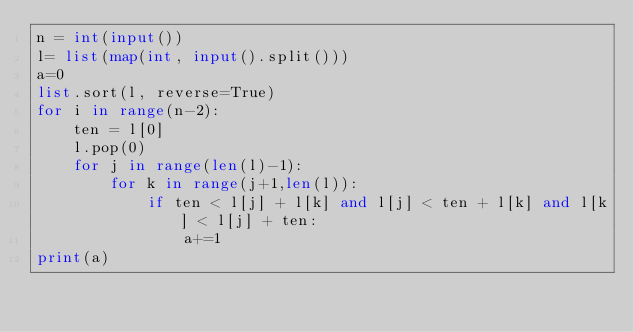Convert code to text. <code><loc_0><loc_0><loc_500><loc_500><_Python_>n = int(input())
l= list(map(int, input().split()))
a=0
list.sort(l, reverse=True)
for i in range(n-2):
    ten = l[0]
    l.pop(0)
    for j in range(len(l)-1):
        for k in range(j+1,len(l)):
            if ten < l[j] + l[k] and l[j] < ten + l[k] and l[k] < l[j] + ten:
                a+=1
print(a)</code> 